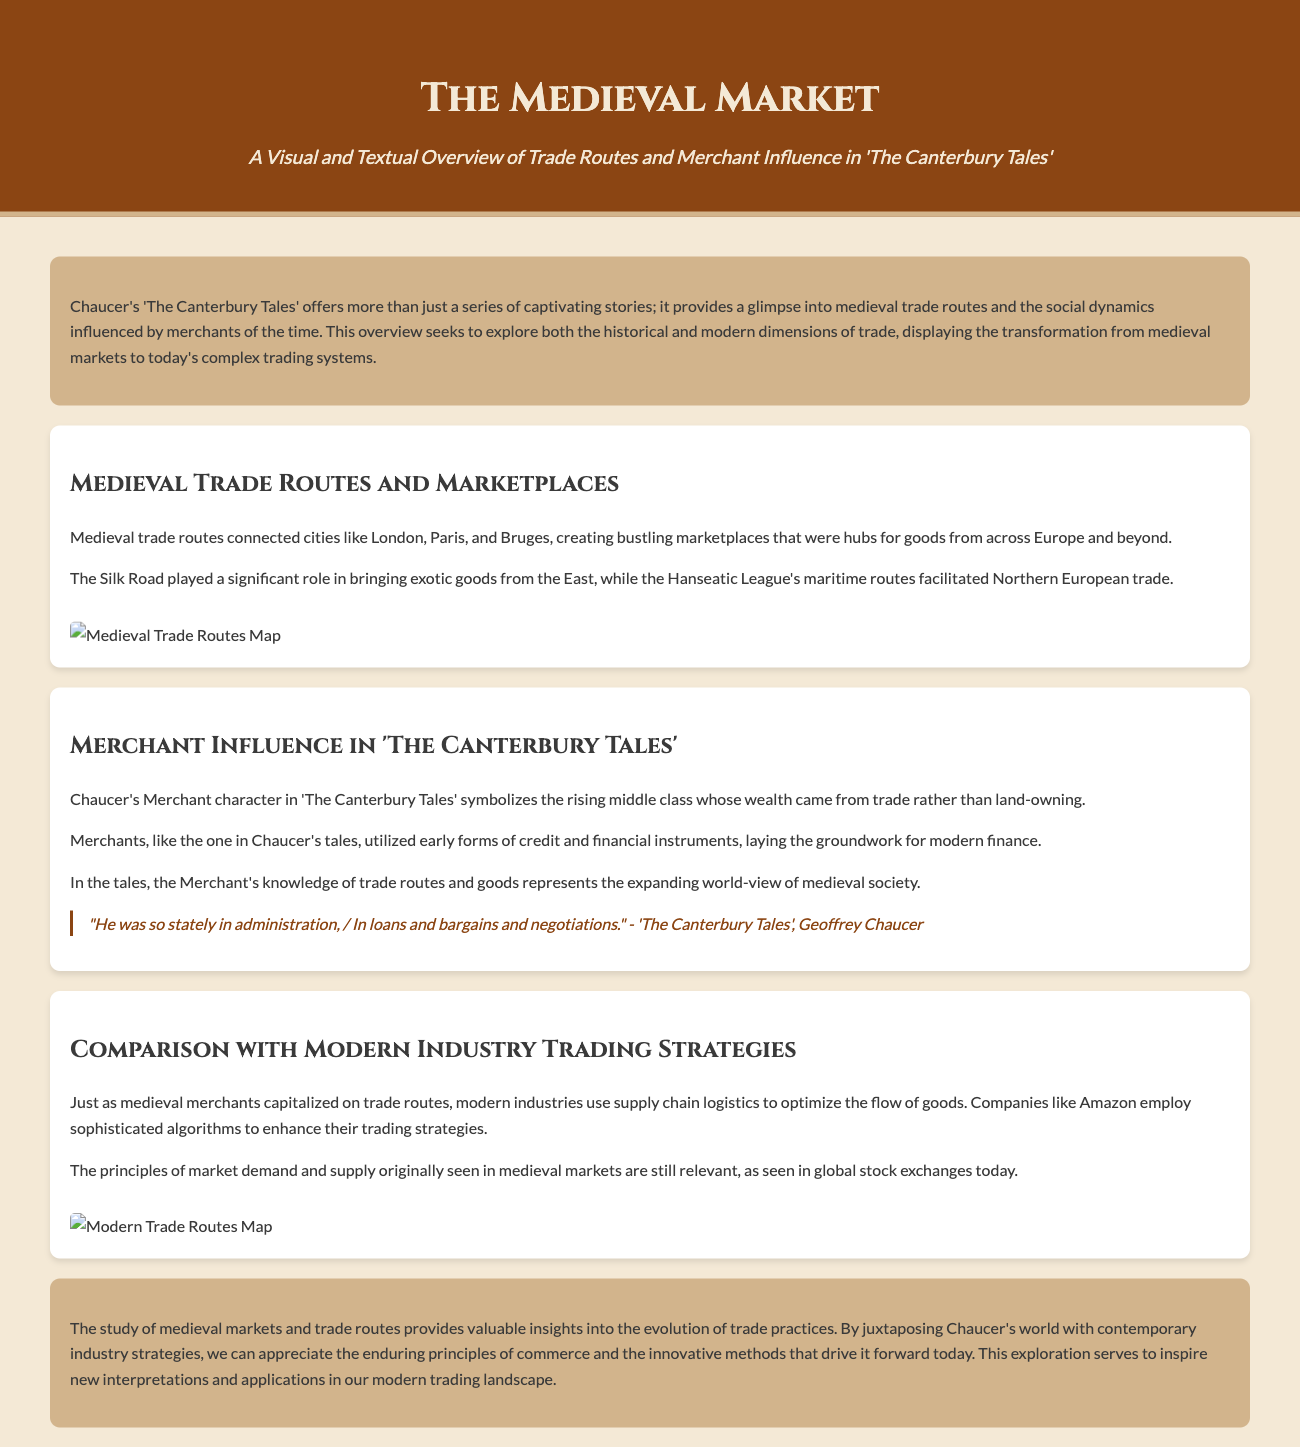What is the title of the document? The title is specified in the header section of the document.
Answer: The Medieval Market: A Visual and Textual Overview of Trade Routes and Merchant Influence in "The Canterbury Tales" Which famous trade route is mentioned? The Silk Road is noted in the context of bringing exotic goods from the East.
Answer: Silk Road What character represents the rising middle class in 'The Canterbury Tales'? The character serves as a symbol of the economic shift from land ownership to trade.
Answer: Merchant What is the main comparison drawn in the document? The document compares medieval trade practices with contemporary industry trading strategies.
Answer: Medieval trade practices and contemporary industry trading strategies Which modern company is mentioned as utilizing trading strategies? The document highlights a well-known company for its optimization of trading strategies through algorithms.
Answer: Amazon What shape of marketplaces did medieval trade routes create? The document describes the nature of medieval trade as fostering bustling areas for commerce.
Answer: Bustling marketplaces Which two cities are mentioned as connected by medieval trade routes? The document lists landmarks that belong to the historical trade network.
Answer: London and Paris What financial methods did medieval merchants utilize? The document discusses the early financial instruments used by traders, representing a shift in economic structures.
Answer: Early forms of credit and financial instruments 